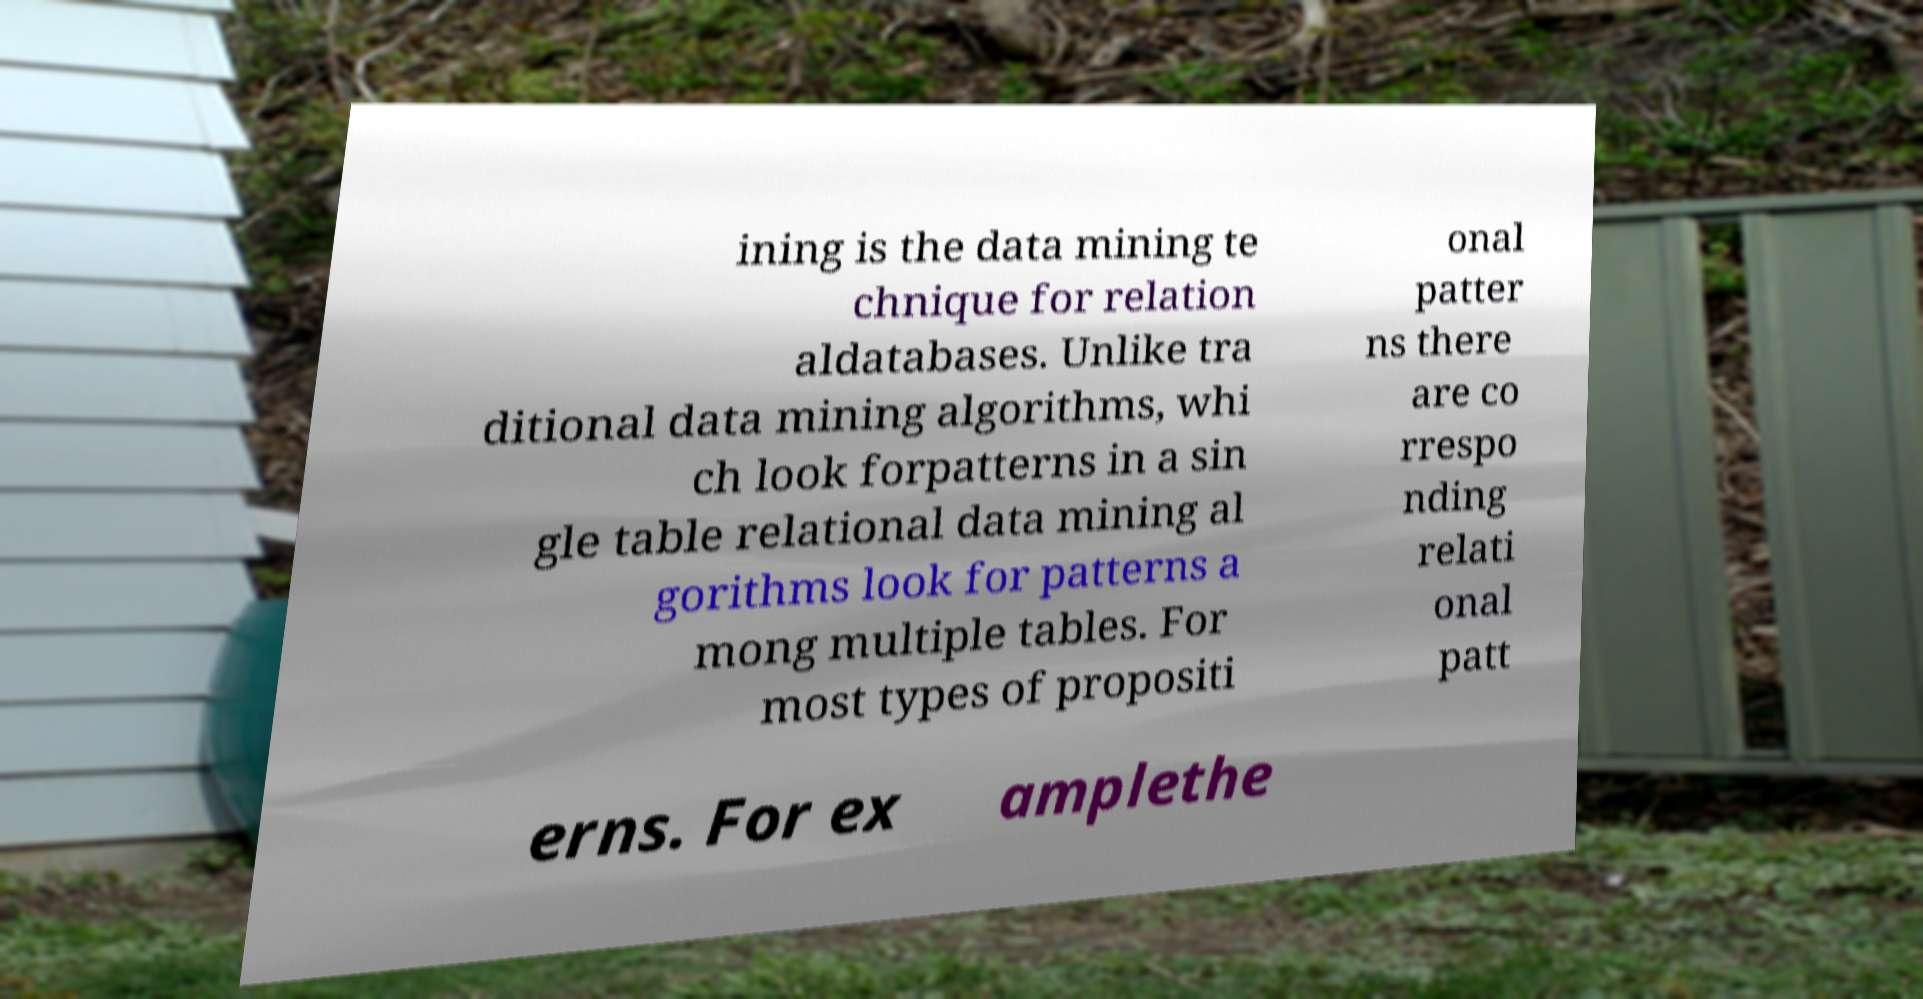There's text embedded in this image that I need extracted. Can you transcribe it verbatim? ining is the data mining te chnique for relation aldatabases. Unlike tra ditional data mining algorithms, whi ch look forpatterns in a sin gle table relational data mining al gorithms look for patterns a mong multiple tables. For most types of propositi onal patter ns there are co rrespo nding relati onal patt erns. For ex amplethe 